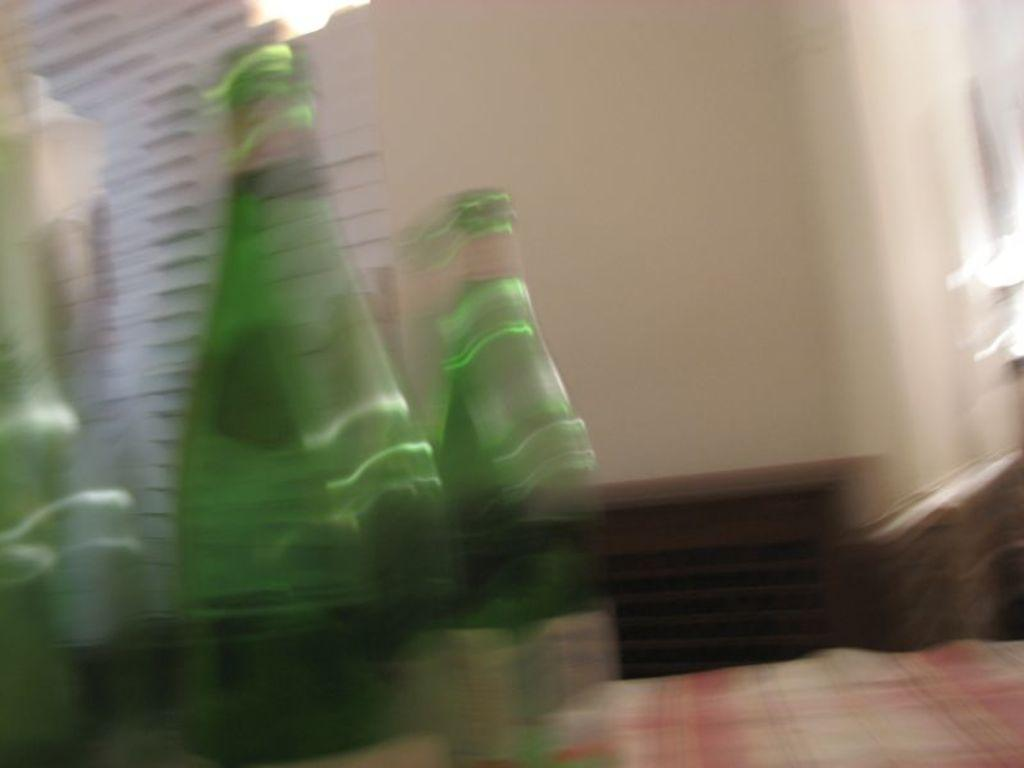How many bottles can be seen in the image? There are 2 bottles in the image. What is visible in the background of the image? There is a wall in the background of the image. What type of growth can be observed on the bottles in the image? There is no growth visible on the bottles in the image. How does the wall push the bottles in the image? The wall does not push the bottles in the image; it is stationary in the background. 